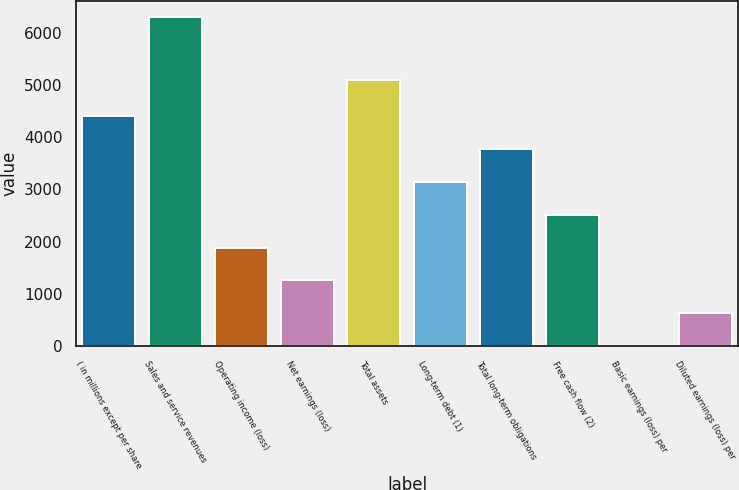Convert chart. <chart><loc_0><loc_0><loc_500><loc_500><bar_chart><fcel>( in millions except per share<fcel>Sales and service revenues<fcel>Operating income (loss)<fcel>Net earnings (loss)<fcel>Total assets<fcel>Long-term debt (1)<fcel>Total long-term obligations<fcel>Free cash flow (2)<fcel>Basic earnings (loss) per<fcel>Diluted earnings (loss) per<nl><fcel>4405.16<fcel>6292<fcel>1889.32<fcel>1260.36<fcel>5097<fcel>3147.24<fcel>3776.2<fcel>2518.28<fcel>2.44<fcel>631.4<nl></chart> 